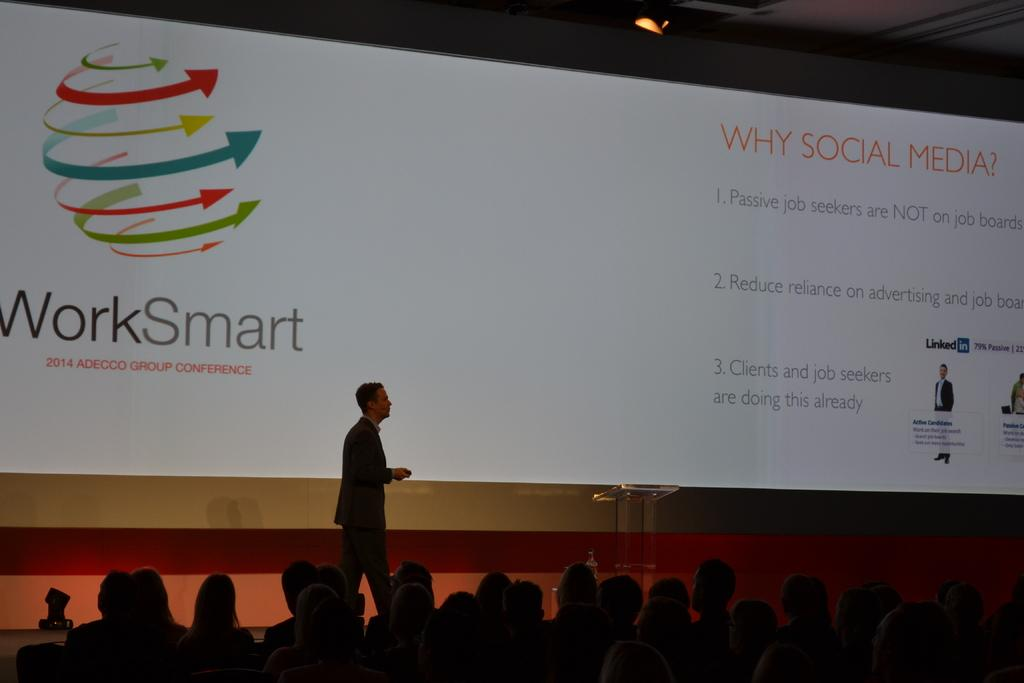What are the people in the image doing? The people in the image are sitting. What is the man in the image doing? The man in the image is walking. What can be seen on the wall in the image? There is a screen visible in the image. What is the source of light in the image? There is light visible at the top of the image. What type of music can be heard playing on the sidewalk in the image? There is no sidewalk or music present in the image. 